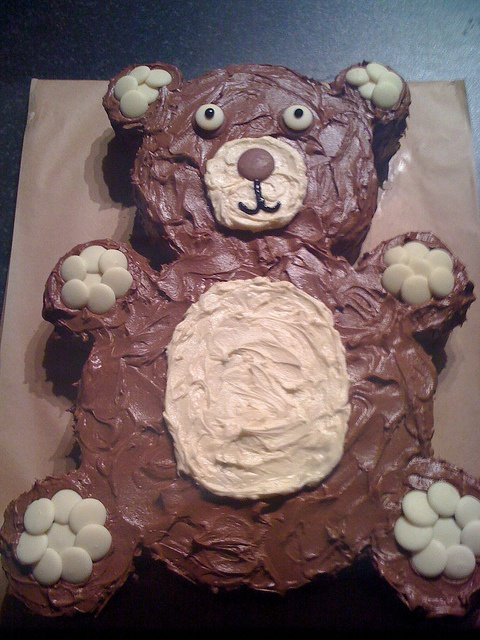Describe the objects in this image and their specific colors. I can see a cake in black, brown, maroon, darkgray, and gray tones in this image. 